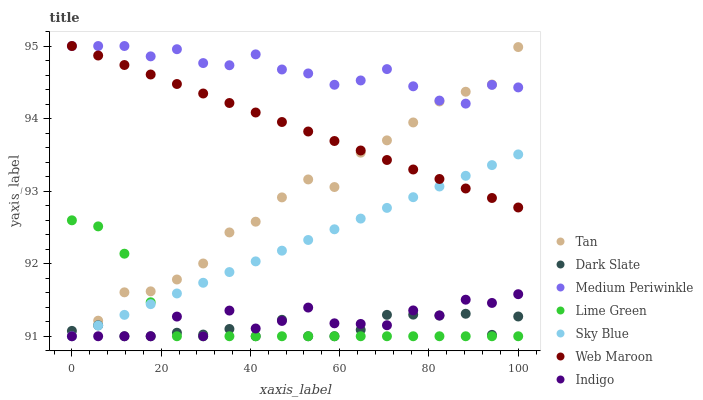Does Dark Slate have the minimum area under the curve?
Answer yes or no. Yes. Does Medium Periwinkle have the maximum area under the curve?
Answer yes or no. Yes. Does Web Maroon have the minimum area under the curve?
Answer yes or no. No. Does Web Maroon have the maximum area under the curve?
Answer yes or no. No. Is Sky Blue the smoothest?
Answer yes or no. Yes. Is Indigo the roughest?
Answer yes or no. Yes. Is Medium Periwinkle the smoothest?
Answer yes or no. No. Is Medium Periwinkle the roughest?
Answer yes or no. No. Does Indigo have the lowest value?
Answer yes or no. Yes. Does Web Maroon have the lowest value?
Answer yes or no. No. Does Web Maroon have the highest value?
Answer yes or no. Yes. Does Dark Slate have the highest value?
Answer yes or no. No. Is Dark Slate less than Web Maroon?
Answer yes or no. Yes. Is Medium Periwinkle greater than Indigo?
Answer yes or no. Yes. Does Web Maroon intersect Medium Periwinkle?
Answer yes or no. Yes. Is Web Maroon less than Medium Periwinkle?
Answer yes or no. No. Is Web Maroon greater than Medium Periwinkle?
Answer yes or no. No. Does Dark Slate intersect Web Maroon?
Answer yes or no. No. 